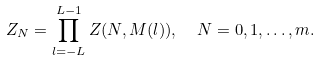<formula> <loc_0><loc_0><loc_500><loc_500>Z _ { N } = \prod _ { l = - L } ^ { L - 1 } Z ( N , M ( l ) ) , \ \ N = 0 , 1 , \dots , m .</formula> 